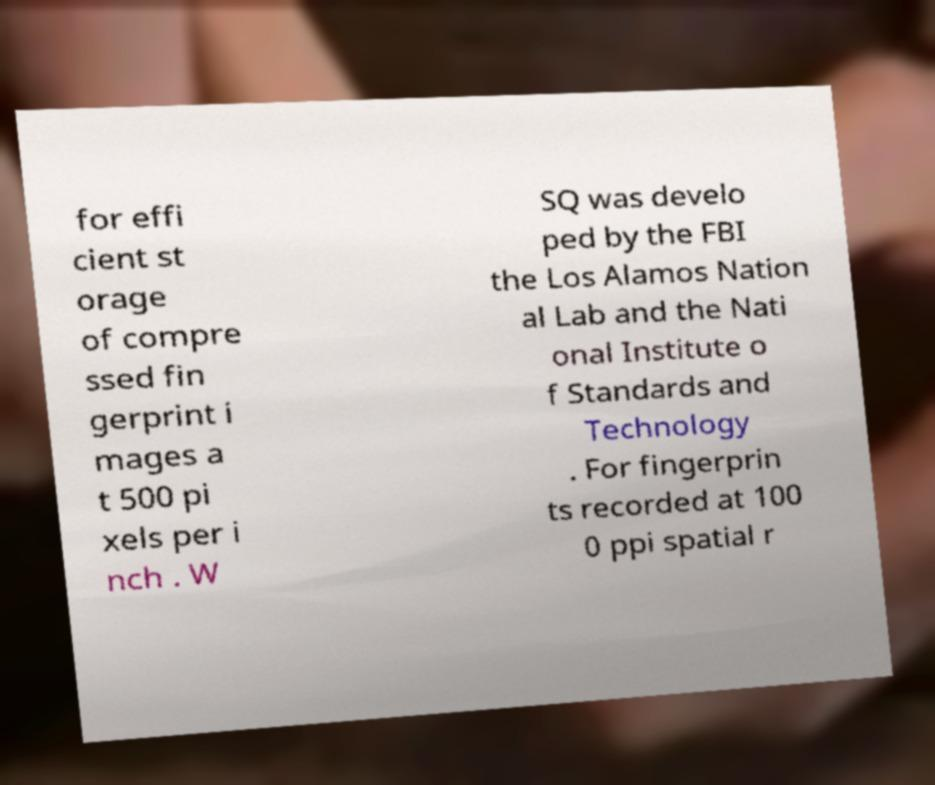What messages or text are displayed in this image? I need them in a readable, typed format. for effi cient st orage of compre ssed fin gerprint i mages a t 500 pi xels per i nch . W SQ was develo ped by the FBI the Los Alamos Nation al Lab and the Nati onal Institute o f Standards and Technology . For fingerprin ts recorded at 100 0 ppi spatial r 